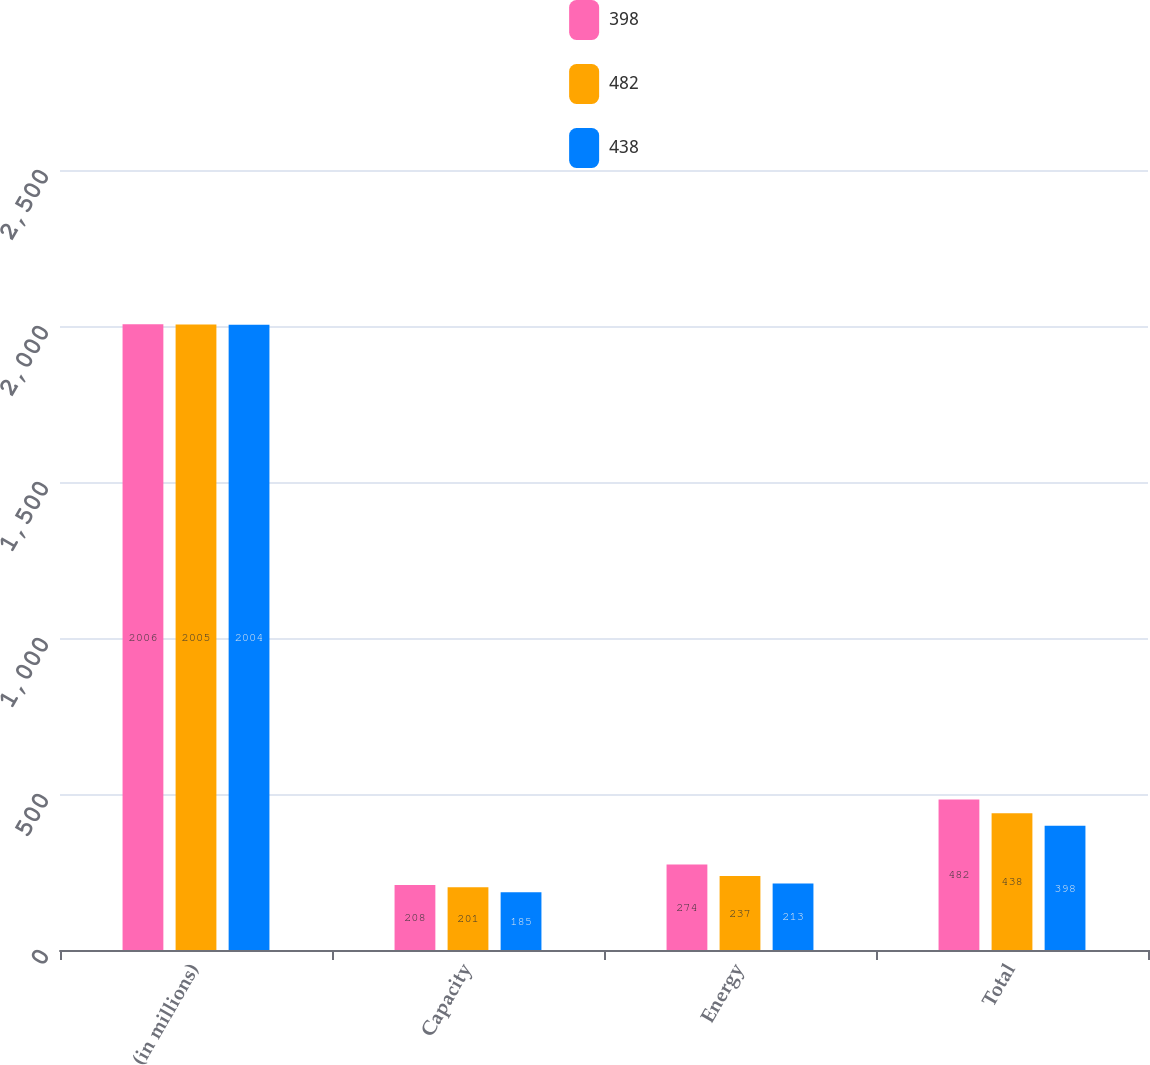Convert chart. <chart><loc_0><loc_0><loc_500><loc_500><stacked_bar_chart><ecel><fcel>(in millions)<fcel>Capacity<fcel>Energy<fcel>Total<nl><fcel>398<fcel>2006<fcel>208<fcel>274<fcel>482<nl><fcel>482<fcel>2005<fcel>201<fcel>237<fcel>438<nl><fcel>438<fcel>2004<fcel>185<fcel>213<fcel>398<nl></chart> 